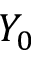Convert formula to latex. <formula><loc_0><loc_0><loc_500><loc_500>Y _ { 0 }</formula> 